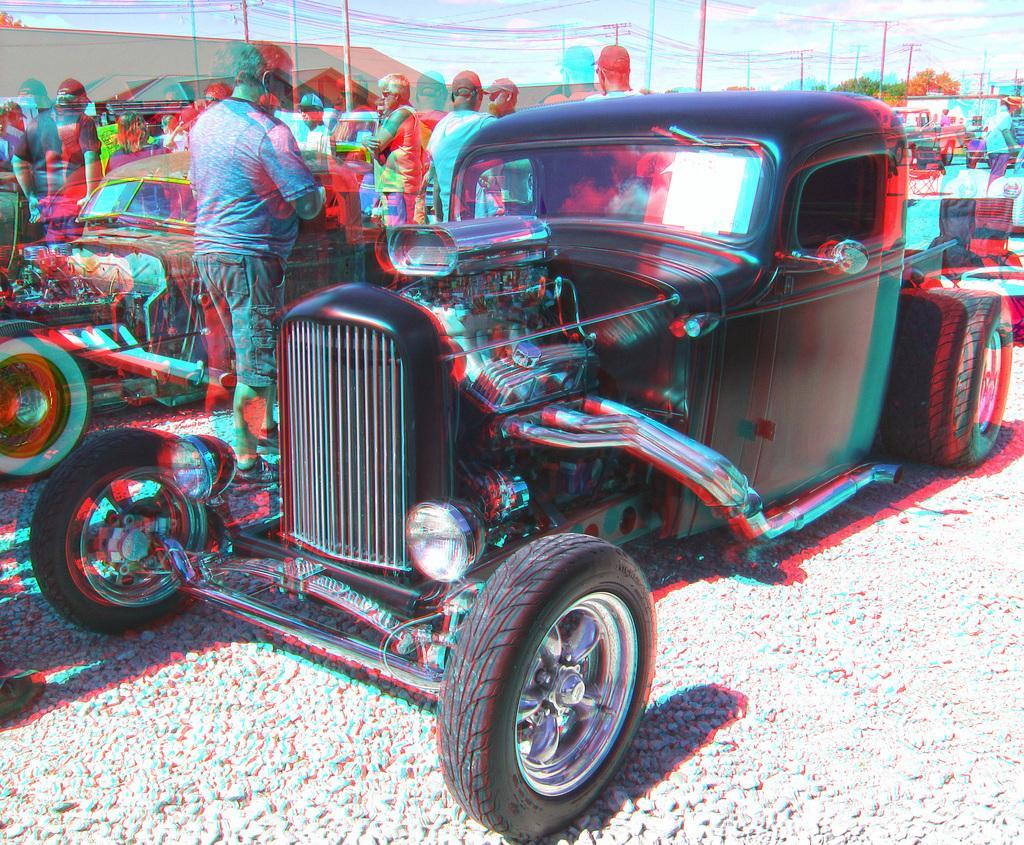Please provide a concise description of this image. In this image, we can see vehicles on the ground and in the background, there are tents, people, trees and poles along with wires. 